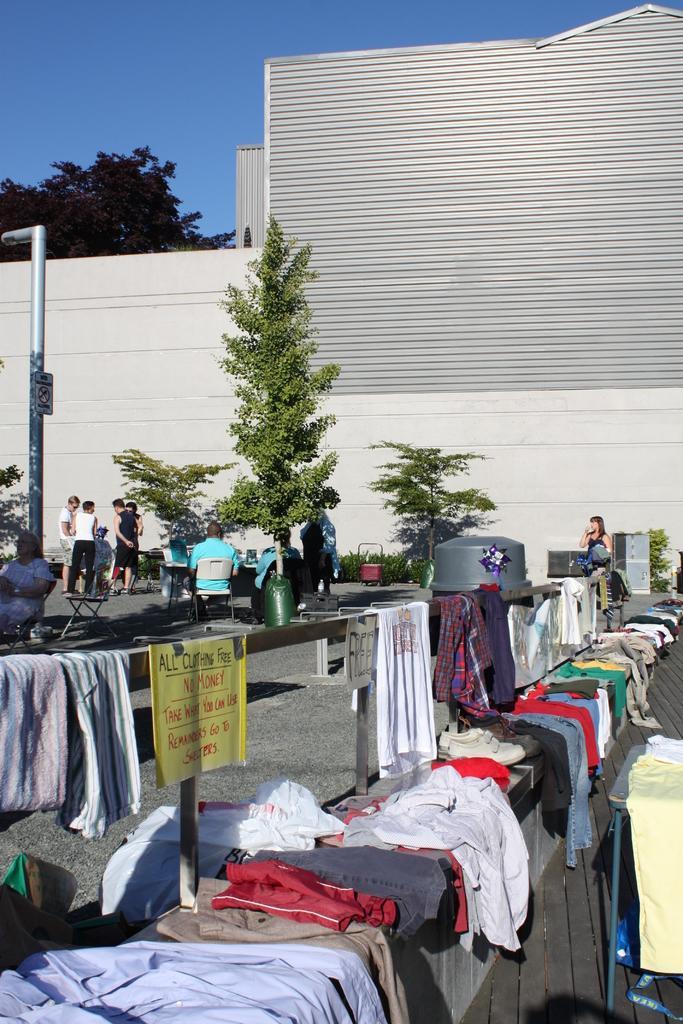Could you give a brief overview of what you see in this image? In this image we can see clothes on a wooden object at the bottom, and there are some persons and trees in the middle of this image, and there is a wall in the background. We can see a tree and a sky at the top of this image. 